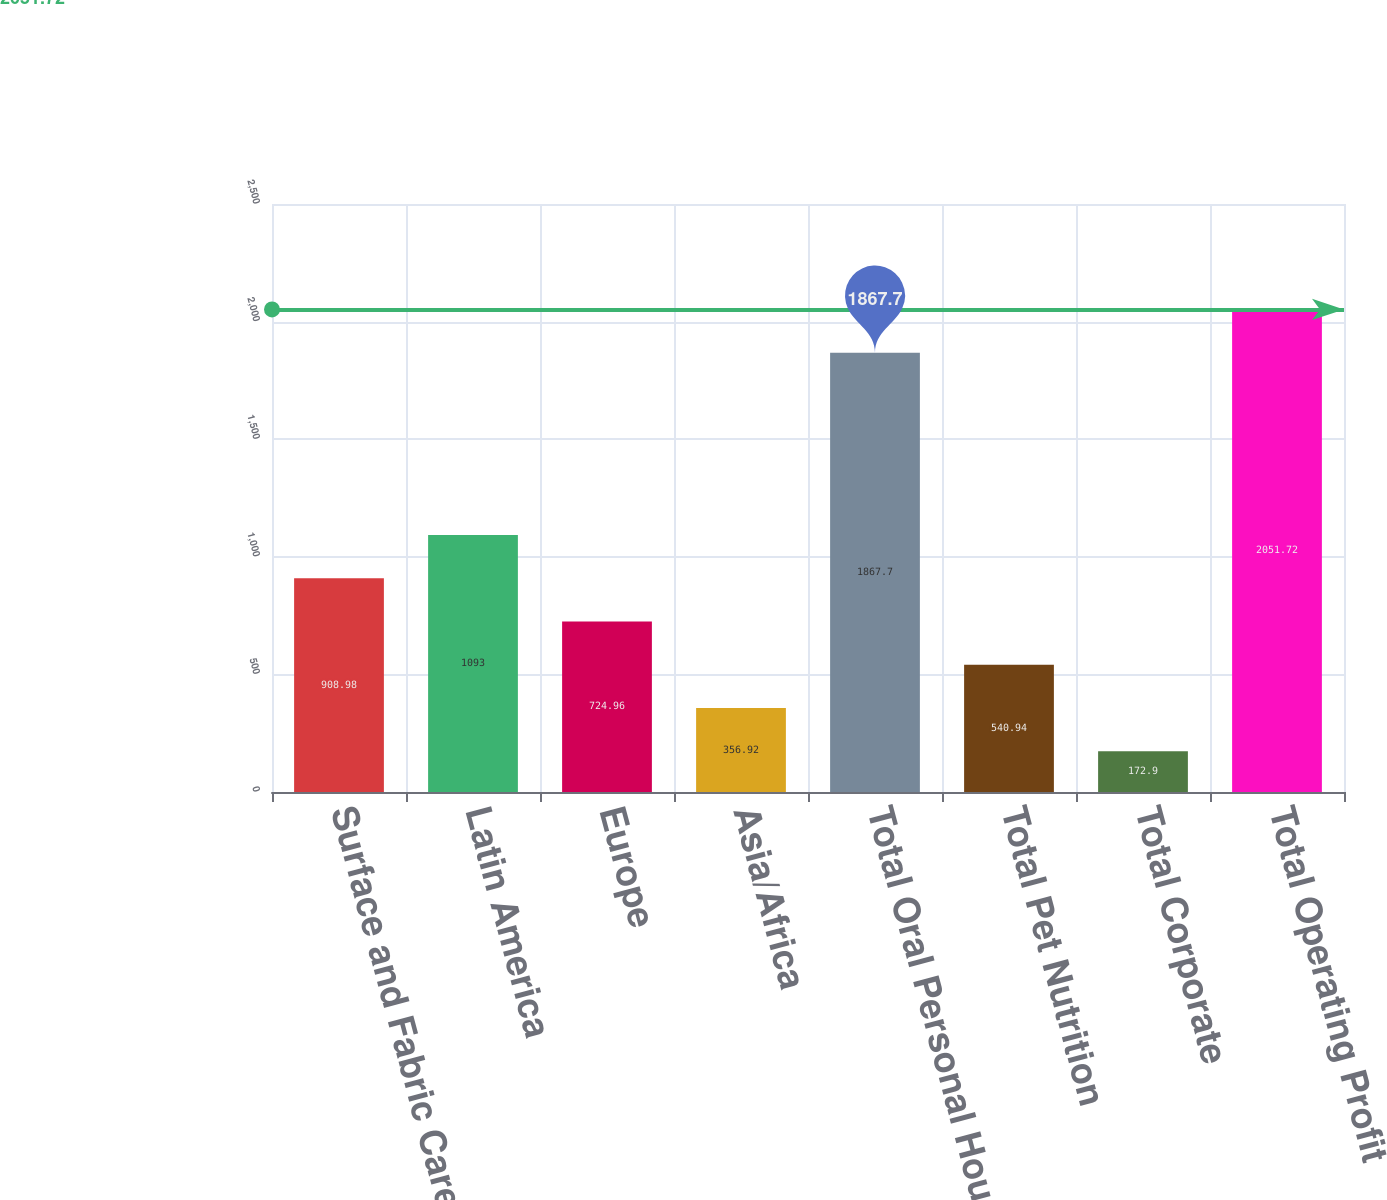<chart> <loc_0><loc_0><loc_500><loc_500><bar_chart><fcel>Surface and Fabric Care North<fcel>Latin America<fcel>Europe<fcel>Asia/Africa<fcel>Total Oral Personal Household<fcel>Total Pet Nutrition<fcel>Total Corporate<fcel>Total Operating Profit<nl><fcel>908.98<fcel>1093<fcel>724.96<fcel>356.92<fcel>1867.7<fcel>540.94<fcel>172.9<fcel>2051.72<nl></chart> 